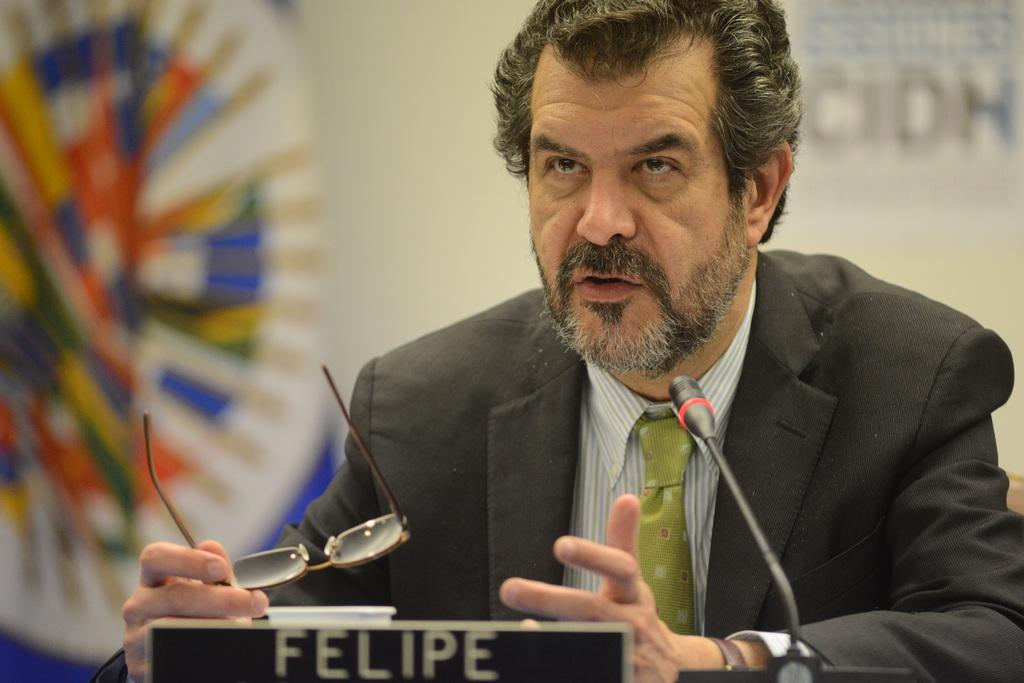What is happening in the image? There is a person in the image who is talking. What is the person holding? The person is holding spectacles. What object is in front of the person? There is a microphone and a board with text in front of the person. How can you describe the background of the image? The background of the image is blurred. What type of wood is used to make the sofa in the image? There is no sofa present in the image. How many quarters can be seen on the board in the image? There are no quarters visible on the board in the image; it contains text. 